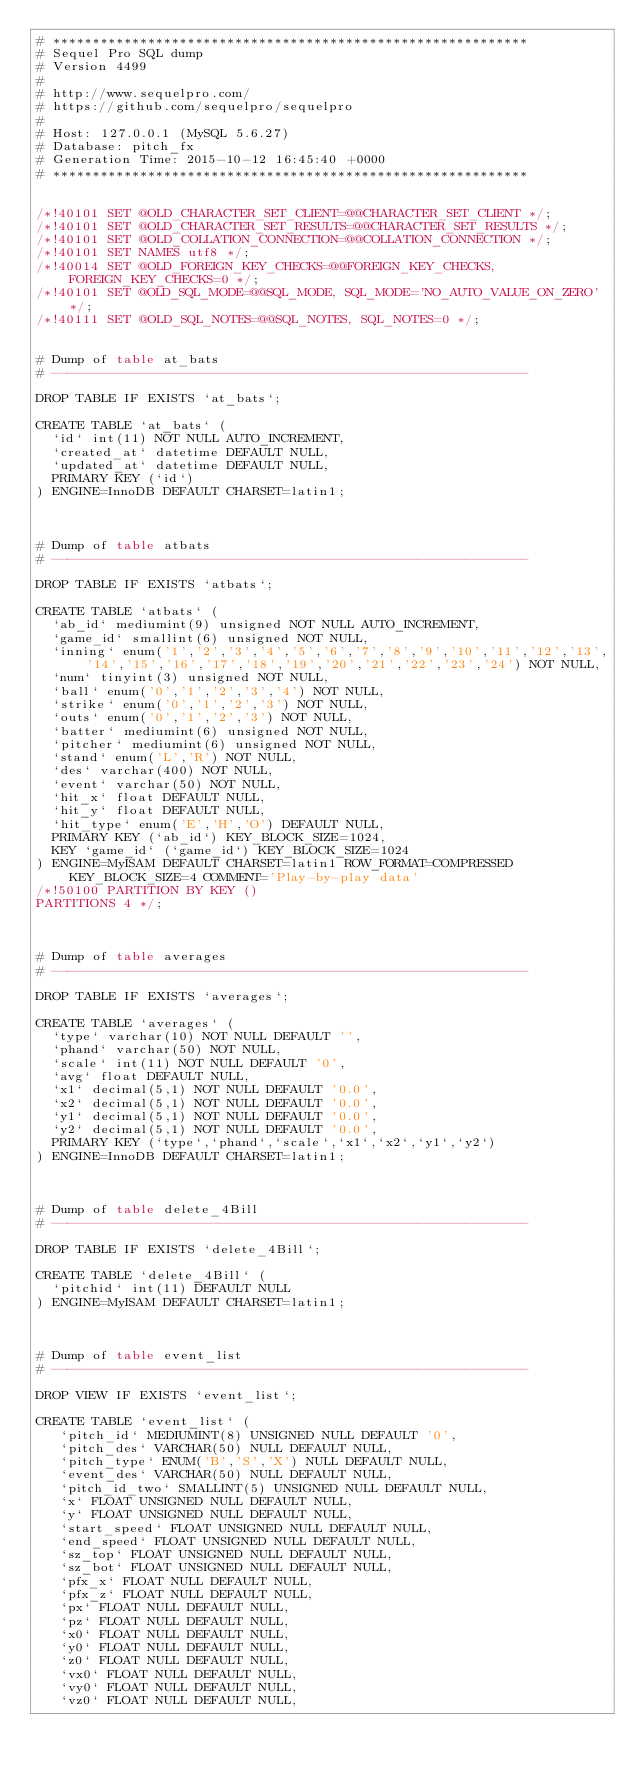Convert code to text. <code><loc_0><loc_0><loc_500><loc_500><_SQL_># ************************************************************
# Sequel Pro SQL dump
# Version 4499
#
# http://www.sequelpro.com/
# https://github.com/sequelpro/sequelpro
#
# Host: 127.0.0.1 (MySQL 5.6.27)
# Database: pitch_fx
# Generation Time: 2015-10-12 16:45:40 +0000
# ************************************************************


/*!40101 SET @OLD_CHARACTER_SET_CLIENT=@@CHARACTER_SET_CLIENT */;
/*!40101 SET @OLD_CHARACTER_SET_RESULTS=@@CHARACTER_SET_RESULTS */;
/*!40101 SET @OLD_COLLATION_CONNECTION=@@COLLATION_CONNECTION */;
/*!40101 SET NAMES utf8 */;
/*!40014 SET @OLD_FOREIGN_KEY_CHECKS=@@FOREIGN_KEY_CHECKS, FOREIGN_KEY_CHECKS=0 */;
/*!40101 SET @OLD_SQL_MODE=@@SQL_MODE, SQL_MODE='NO_AUTO_VALUE_ON_ZERO' */;
/*!40111 SET @OLD_SQL_NOTES=@@SQL_NOTES, SQL_NOTES=0 */;


# Dump of table at_bats
# ------------------------------------------------------------

DROP TABLE IF EXISTS `at_bats`;

CREATE TABLE `at_bats` (
  `id` int(11) NOT NULL AUTO_INCREMENT,
  `created_at` datetime DEFAULT NULL,
  `updated_at` datetime DEFAULT NULL,
  PRIMARY KEY (`id`)
) ENGINE=InnoDB DEFAULT CHARSET=latin1;



# Dump of table atbats
# ------------------------------------------------------------

DROP TABLE IF EXISTS `atbats`;

CREATE TABLE `atbats` (
  `ab_id` mediumint(9) unsigned NOT NULL AUTO_INCREMENT,
  `game_id` smallint(6) unsigned NOT NULL,
  `inning` enum('1','2','3','4','5','6','7','8','9','10','11','12','13','14','15','16','17','18','19','20','21','22','23','24') NOT NULL,
  `num` tinyint(3) unsigned NOT NULL,
  `ball` enum('0','1','2','3','4') NOT NULL,
  `strike` enum('0','1','2','3') NOT NULL,
  `outs` enum('0','1','2','3') NOT NULL,
  `batter` mediumint(6) unsigned NOT NULL,
  `pitcher` mediumint(6) unsigned NOT NULL,
  `stand` enum('L','R') NOT NULL,
  `des` varchar(400) NOT NULL,
  `event` varchar(50) NOT NULL,
  `hit_x` float DEFAULT NULL,
  `hit_y` float DEFAULT NULL,
  `hit_type` enum('E','H','O') DEFAULT NULL,
  PRIMARY KEY (`ab_id`) KEY_BLOCK_SIZE=1024,
  KEY `game_id` (`game_id`) KEY_BLOCK_SIZE=1024
) ENGINE=MyISAM DEFAULT CHARSET=latin1 ROW_FORMAT=COMPRESSED KEY_BLOCK_SIZE=4 COMMENT='Play-by-play data'
/*!50100 PARTITION BY KEY ()
PARTITIONS 4 */;



# Dump of table averages
# ------------------------------------------------------------

DROP TABLE IF EXISTS `averages`;

CREATE TABLE `averages` (
  `type` varchar(10) NOT NULL DEFAULT '',
  `phand` varchar(50) NOT NULL,
  `scale` int(11) NOT NULL DEFAULT '0',
  `avg` float DEFAULT NULL,
  `x1` decimal(5,1) NOT NULL DEFAULT '0.0',
  `x2` decimal(5,1) NOT NULL DEFAULT '0.0',
  `y1` decimal(5,1) NOT NULL DEFAULT '0.0',
  `y2` decimal(5,1) NOT NULL DEFAULT '0.0',
  PRIMARY KEY (`type`,`phand`,`scale`,`x1`,`x2`,`y1`,`y2`)
) ENGINE=InnoDB DEFAULT CHARSET=latin1;



# Dump of table delete_4Bill
# ------------------------------------------------------------

DROP TABLE IF EXISTS `delete_4Bill`;

CREATE TABLE `delete_4Bill` (
  `pitchid` int(11) DEFAULT NULL
) ENGINE=MyISAM DEFAULT CHARSET=latin1;



# Dump of table event_list
# ------------------------------------------------------------

DROP VIEW IF EXISTS `event_list`;

CREATE TABLE `event_list` (
   `pitch_id` MEDIUMINT(8) UNSIGNED NULL DEFAULT '0',
   `pitch_des` VARCHAR(50) NULL DEFAULT NULL,
   `pitch_type` ENUM('B','S','X') NULL DEFAULT NULL,
   `event_des` VARCHAR(50) NULL DEFAULT NULL,
   `pitch_id_two` SMALLINT(5) UNSIGNED NULL DEFAULT NULL,
   `x` FLOAT UNSIGNED NULL DEFAULT NULL,
   `y` FLOAT UNSIGNED NULL DEFAULT NULL,
   `start_speed` FLOAT UNSIGNED NULL DEFAULT NULL,
   `end_speed` FLOAT UNSIGNED NULL DEFAULT NULL,
   `sz_top` FLOAT UNSIGNED NULL DEFAULT NULL,
   `sz_bot` FLOAT UNSIGNED NULL DEFAULT NULL,
   `pfx_x` FLOAT NULL DEFAULT NULL,
   `pfx_z` FLOAT NULL DEFAULT NULL,
   `px` FLOAT NULL DEFAULT NULL,
   `pz` FLOAT NULL DEFAULT NULL,
   `x0` FLOAT NULL DEFAULT NULL,
   `y0` FLOAT NULL DEFAULT NULL,
   `z0` FLOAT NULL DEFAULT NULL,
   `vx0` FLOAT NULL DEFAULT NULL,
   `vy0` FLOAT NULL DEFAULT NULL,
   `vz0` FLOAT NULL DEFAULT NULL,</code> 